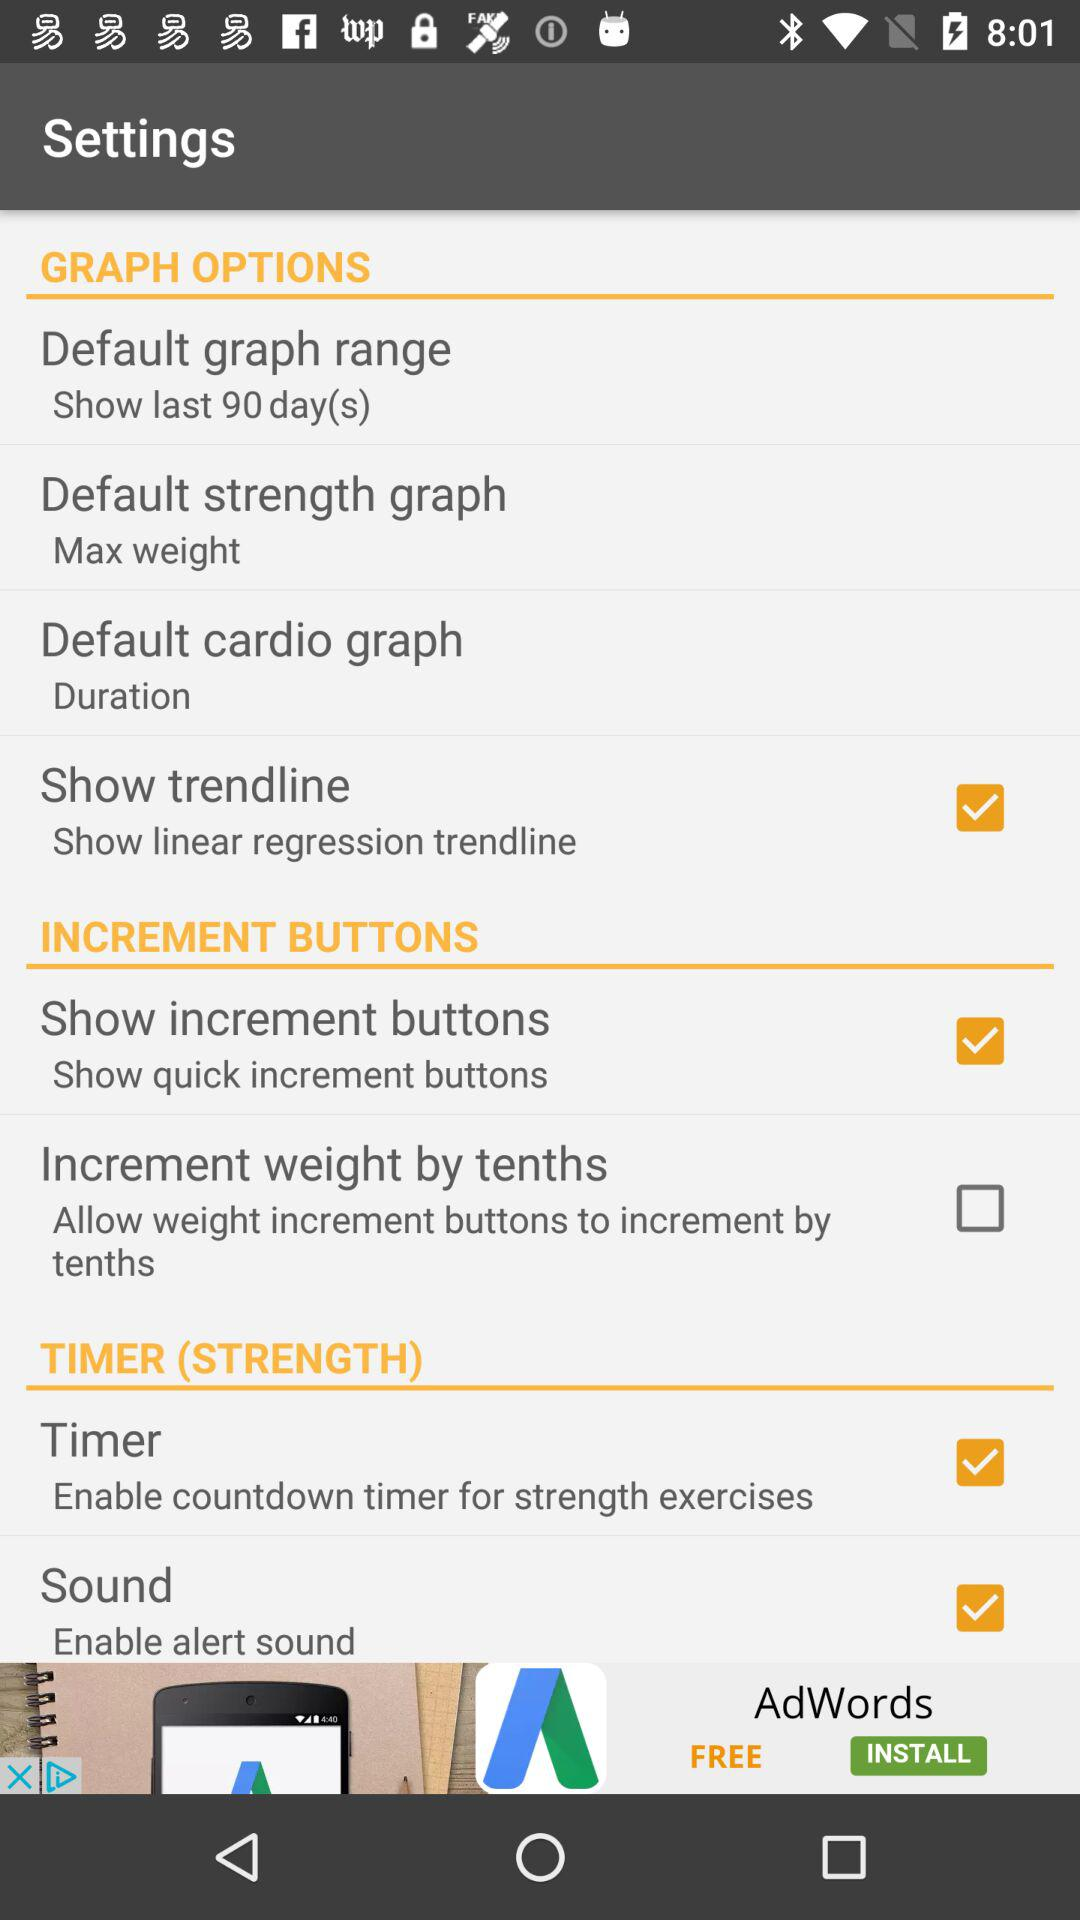What are the selected days for the default graph range? The selected days are the last 90 days. 